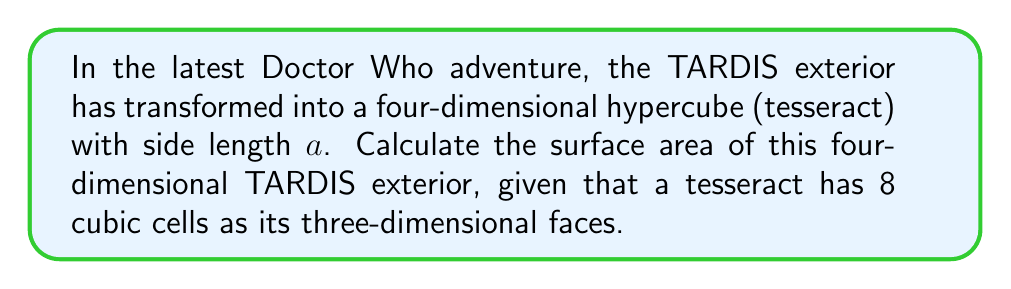Teach me how to tackle this problem. To calculate the surface area of a four-dimensional TARDIS exterior (tesseract), we need to consider the following steps:

1) In a tesseract, the "surface" consists of its three-dimensional faces, which are cubes.

2) A tesseract has 8 cubic cells as its three-dimensional faces.

3) The surface area of a cube with side length $a$ is given by:

   $$SA_{cube} = 6a^2$$

4) Since we have 8 cubic cells, the total surface area of the tesseract will be:

   $$SA_{tesseract} = 8 \times SA_{cube}$$

5) Substituting the formula for the surface area of a cube:

   $$SA_{tesseract} = 8 \times 6a^2 = 48a^2$$

6) Therefore, the surface area of the four-dimensional TARDIS exterior is $48a^2$.

This result shows that the "surface area" of a four-dimensional object is measured in four-dimensional units, which would be the cube of the length unit in our three-dimensional space.
Answer: The surface area of the four-dimensional TARDIS exterior (tesseract) is $48a^2$ square units, where $a$ is the side length of the tesseract. 